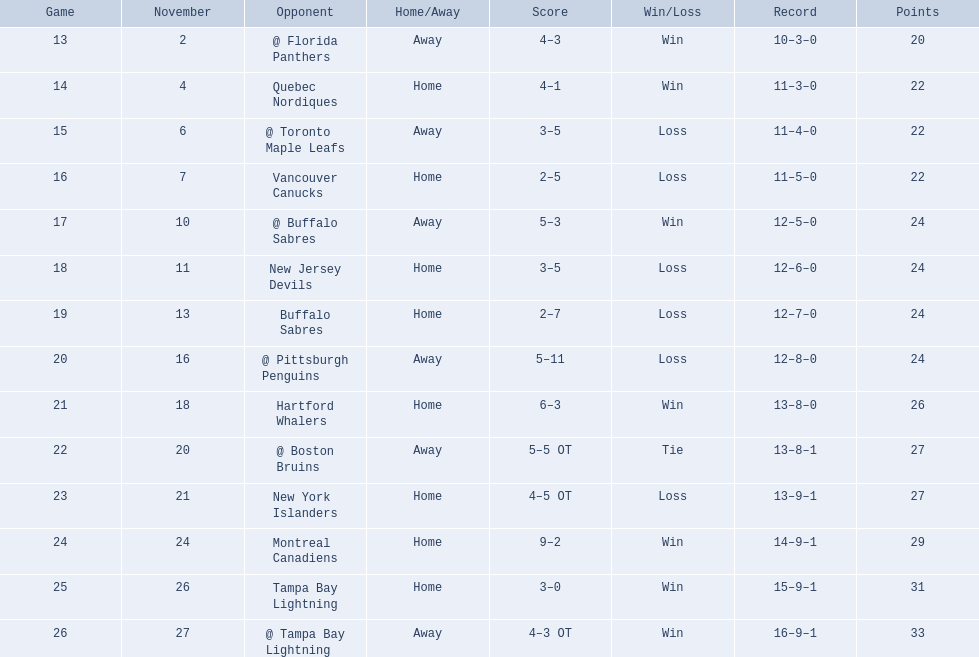What were the scores of the 1993-94 philadelphia flyers season? 4–3, 4–1, 3–5, 2–5, 5–3, 3–5, 2–7, 5–11, 6–3, 5–5 OT, 4–5 OT, 9–2, 3–0, 4–3 OT. Which of these teams had the score 4-5 ot? New York Islanders. 